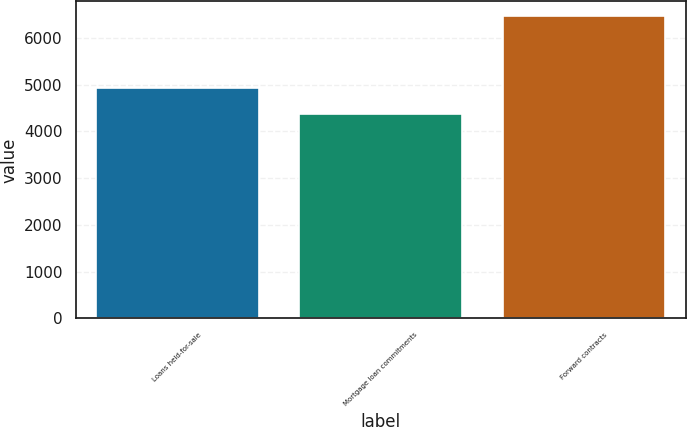<chart> <loc_0><loc_0><loc_500><loc_500><bar_chart><fcel>Loans held-for-sale<fcel>Mortgage loan commitments<fcel>Forward contracts<nl><fcel>4923<fcel>4382<fcel>6461<nl></chart> 